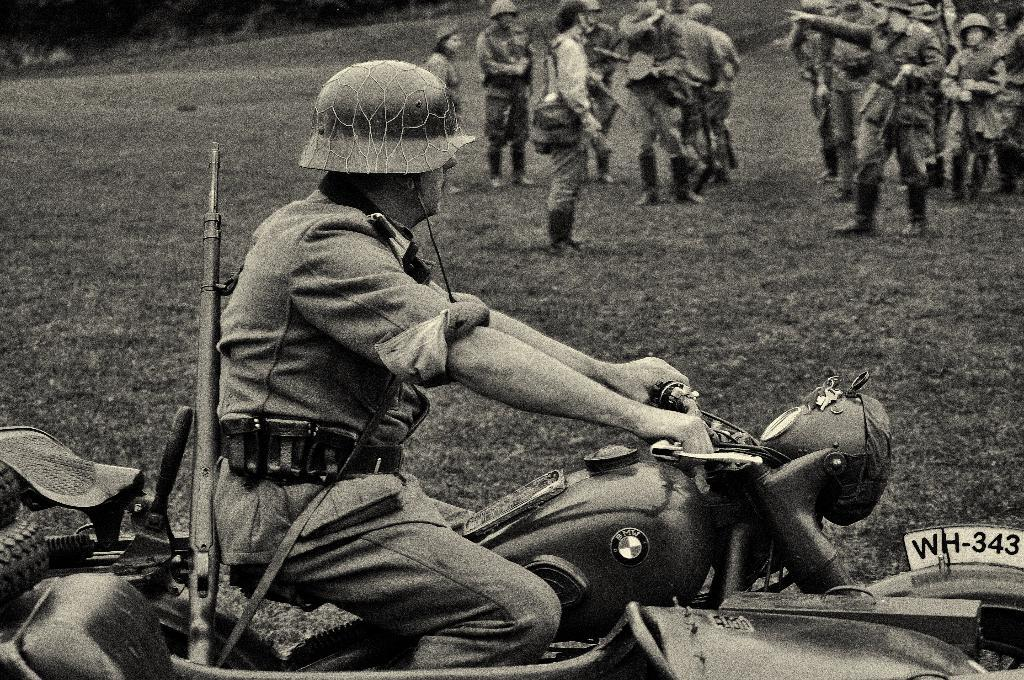What is the man in the image doing? The man is riding a bike in the image. Where is the man riding the bike? The man is on the road. What else can be seen in the image besides the man on the bike? There is a group of persons standing in the image. What type of natural scenery is visible in the image? There are trees visible in the image. What type of ear is the judge wearing in the image? There is no judge or ear present in the image; it features a man riding a bike on the road with a group of persons and trees in the background. 